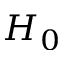<formula> <loc_0><loc_0><loc_500><loc_500>H _ { 0 }</formula> 